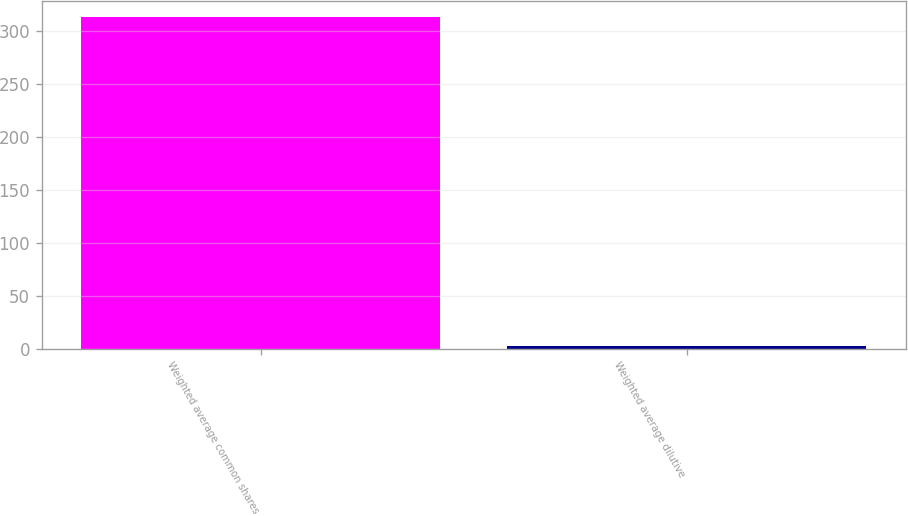Convert chart to OTSL. <chart><loc_0><loc_0><loc_500><loc_500><bar_chart><fcel>Weighted average common shares<fcel>Weighted average dilutive<nl><fcel>312.95<fcel>2.3<nl></chart> 